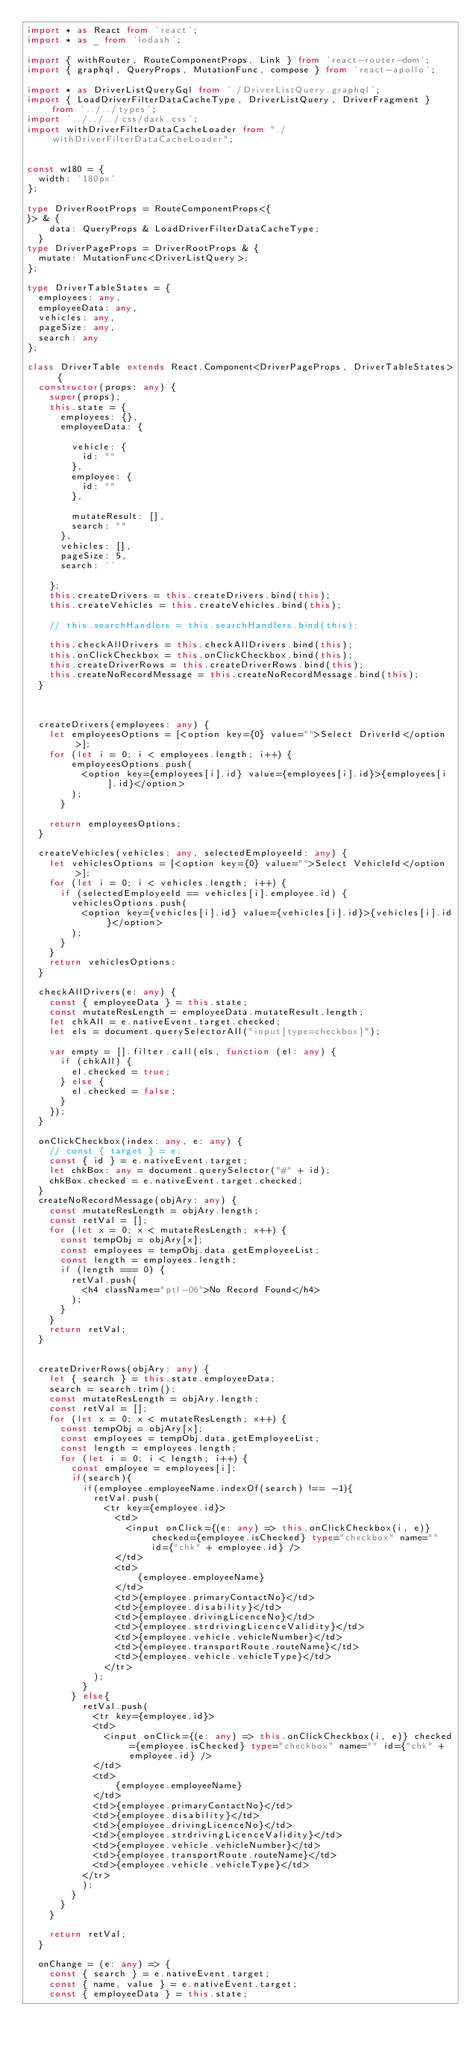Convert code to text. <code><loc_0><loc_0><loc_500><loc_500><_TypeScript_>import * as React from 'react';
import * as _ from 'lodash';

import { withRouter, RouteComponentProps, Link } from 'react-router-dom';
import { graphql, QueryProps, MutationFunc, compose } from 'react-apollo';

import * as DriverListQueryGql from './DriverListQuery.graphql';
import { LoadDriverFilterDataCacheType, DriverListQuery, DriverFragment } from '../../types';
import '../../../css/dark.css';
import withDriverFilterDataCacheLoader from "./withDriverFilterDataCacheLoader";


const w180 = {
  width: '180px'
};

type DriverRootProps = RouteComponentProps<{
}> & {
    data: QueryProps & LoadDriverFilterDataCacheType;
  }
type DriverPageProps = DriverRootProps & {
  mutate: MutationFunc<DriverListQuery>;
};

type DriverTableStates = {
  employees: any,
  employeeData: any,
  vehicles: any,
  pageSize: any,
  search: any
};

class DriverTable extends React.Component<DriverPageProps, DriverTableStates> {
  constructor(props: any) {
    super(props);
    this.state = {
      employees: {},
      employeeData: {
       
        vehicle: {
          id: ""
        },
        employee: {
          id: ""
        },
      
        mutateResult: [],
        search: ""
      },
      vehicles: [],
      pageSize: 5,
      search: ''

    };
    this.createDrivers = this.createDrivers.bind(this);
    this.createVehicles = this.createVehicles.bind(this);
   
    // this.searchHandlers = this.searchHandlers.bind(this);

    this.checkAllDrivers = this.checkAllDrivers.bind(this);
    this.onClickCheckbox = this.onClickCheckbox.bind(this);
    this.createDriverRows = this.createDriverRows.bind(this);
    this.createNoRecordMessage = this.createNoRecordMessage.bind(this);
  }



  createDrivers(employees: any) {
    let employeesOptions = [<option key={0} value="">Select DriverId</option>];
    for (let i = 0; i < employees.length; i++) {
        employeesOptions.push(
          <option key={employees[i].id} value={employees[i].id}>{employees[i].id}</option>
        );
      }
    
    return employeesOptions;
  }

  createVehicles(vehicles: any, selectedEmployeeId: any) {
    let vehiclesOptions = [<option key={0} value="">Select VehicleId</option>];
    for (let i = 0; i < vehicles.length; i++) {
      if (selectedEmployeeId == vehicles[i].employee.id) {
        vehiclesOptions.push(
          <option key={vehicles[i].id} value={vehicles[i].id}>{vehicles[i].id}</option>
        );
      }
    }
    return vehiclesOptions;
  }

  checkAllDrivers(e: any) {
    const { employeeData } = this.state;
    const mutateResLength = employeeData.mutateResult.length;
    let chkAll = e.nativeEvent.target.checked;
    let els = document.querySelectorAll("input[type=checkbox]");

    var empty = [].filter.call(els, function (el: any) {
      if (chkAll) {
        el.checked = true;
      } else {
        el.checked = false;
      }
    });
  }

  onClickCheckbox(index: any, e: any) {
    // const { target } = e;
    const { id } = e.nativeEvent.target;
    let chkBox: any = document.querySelector("#" + id);
    chkBox.checked = e.nativeEvent.target.checked;
  }
  createNoRecordMessage(objAry: any) {
    const mutateResLength = objAry.length;
    const retVal = [];
    for (let x = 0; x < mutateResLength; x++) {
      const tempObj = objAry[x];
      const employees = tempObj.data.getEmployeeList;
      const length = employees.length;
      if (length === 0) {
        retVal.push(
          <h4 className="ptl-06">No Record Found</h4>
        );
      }
    }
    return retVal;
  }


  createDriverRows(objAry: any) {
    let { search } = this.state.employeeData;
    search = search.trim();
    const mutateResLength = objAry.length;
    const retVal = [];
    for (let x = 0; x < mutateResLength; x++) {
      const tempObj = objAry[x];
      const employees = tempObj.data.getEmployeeList;
      const length = employees.length;
      for (let i = 0; i < length; i++) {
        const employee = employees[i];
        if(search){
          if(employee.employeeName.indexOf(search) !== -1){
            retVal.push(
              <tr key={employee.id}>
                <td>
                  <input onClick={(e: any) => this.onClickCheckbox(i, e)} checked={employee.isChecked} type="checkbox" name="" id={"chk" + employee.id} />
                </td>
                <td>
                    {employee.employeeName}
                </td>
                <td>{employee.primaryContactNo}</td>
                <td>{employee.disability}</td>
                <td>{employee.drivingLicenceNo}</td>
                <td>{employee.strdrivingLicenceValidity}</td>
                <td>{employee.vehicle.vehicleNumber}</td>
                <td>{employee.transportRoute.routeName}</td>
                <td>{employee.vehicle.vehicleType}</td>
              </tr>
            );
          }
        } else{
          retVal.push(
            <tr key={employee.id}>
            <td>
              <input onClick={(e: any) => this.onClickCheckbox(i, e)} checked={employee.isChecked} type="checkbox" name="" id={"chk" + employee.id} />
            </td>
            <td>
                {employee.employeeName}
            </td>
            <td>{employee.primaryContactNo}</td>
            <td>{employee.disability}</td>
            <td>{employee.drivingLicenceNo}</td>
            <td>{employee.strdrivingLicenceValidity}</td>
            <td>{employee.vehicle.vehicleNumber}</td>
            <td>{employee.transportRoute.routeName}</td>
            <td>{employee.vehicle.vehicleType}</td>
          </tr>
          );
        }
      }
    }

    return retVal;
  }

  onChange = (e: any) => {
    const { search } = e.nativeEvent.target;
    const { name, value } = e.nativeEvent.target;
    const { employeeData } = this.state;</code> 